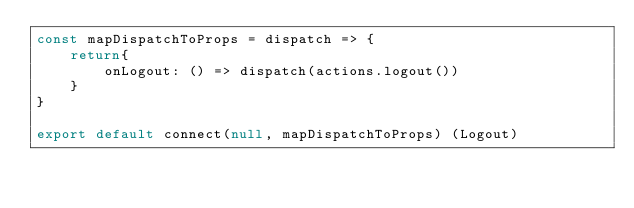Convert code to text. <code><loc_0><loc_0><loc_500><loc_500><_JavaScript_>const mapDispatchToProps = dispatch => {
    return{
        onLogout: () => dispatch(actions.logout())
    }
}

export default connect(null, mapDispatchToProps) (Logout)</code> 